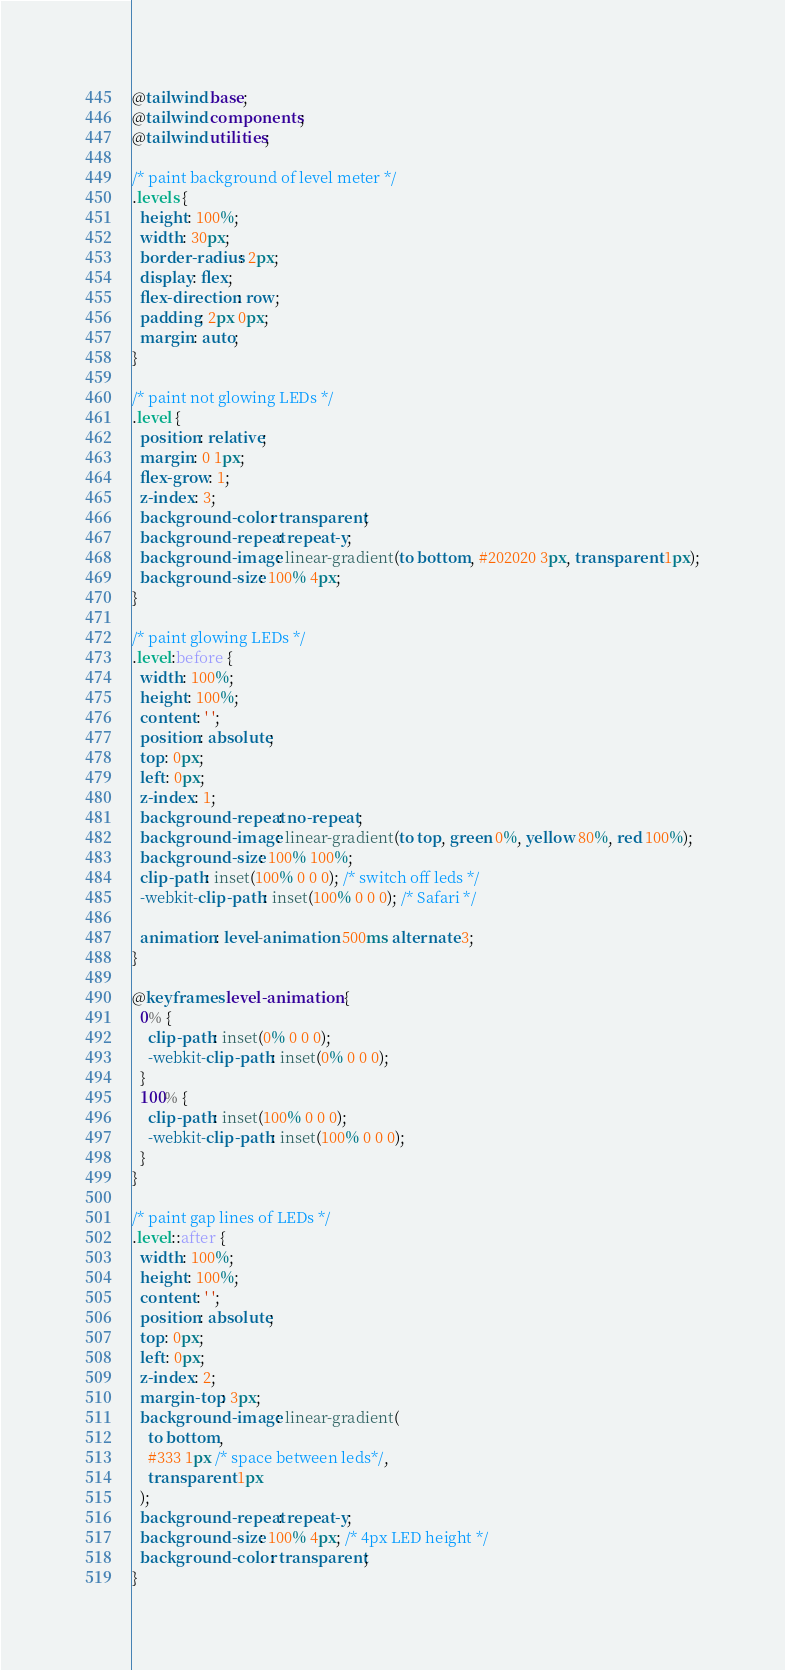<code> <loc_0><loc_0><loc_500><loc_500><_CSS_>@tailwind base;
@tailwind components;
@tailwind utilities;

/* paint background of level meter */
.levels {
  height: 100%;
  width: 30px;
  border-radius: 2px;
  display: flex;
  flex-direction: row;
  padding: 2px 0px;
  margin: auto;
}

/* paint not glowing LEDs */
.level {
  position: relative;
  margin: 0 1px;
  flex-grow: 1;
  z-index: 3;
  background-color: transparent;
  background-repeat: repeat-y;
  background-image: linear-gradient(to bottom, #202020 3px, transparent 1px);
  background-size: 100% 4px;
}

/* paint glowing LEDs */
.level:before {
  width: 100%;
  height: 100%;
  content: ' ';
  position: absolute;
  top: 0px;
  left: 0px;
  z-index: 1;
  background-repeat: no-repeat;
  background-image: linear-gradient(to top, green 0%, yellow 80%, red 100%);
  background-size: 100% 100%;
  clip-path: inset(100% 0 0 0); /* switch off leds */
  -webkit-clip-path: inset(100% 0 0 0); /* Safari */

  animation: level-animation 500ms alternate 3;
}

@keyframes level-animation {
  0% {
    clip-path: inset(0% 0 0 0);
    -webkit-clip-path: inset(0% 0 0 0);
  }
  100% {
    clip-path: inset(100% 0 0 0);
    -webkit-clip-path: inset(100% 0 0 0);
  }
}

/* paint gap lines of LEDs */
.level::after {
  width: 100%;
  height: 100%;
  content: ' ';
  position: absolute;
  top: 0px;
  left: 0px;
  z-index: 2;
  margin-top: 3px;
  background-image: linear-gradient(
    to bottom,
    #333 1px /* space between leds*/,
    transparent 1px
  );
  background-repeat: repeat-y;
  background-size: 100% 4px; /* 4px LED height */
  background-color: transparent;
}
</code> 